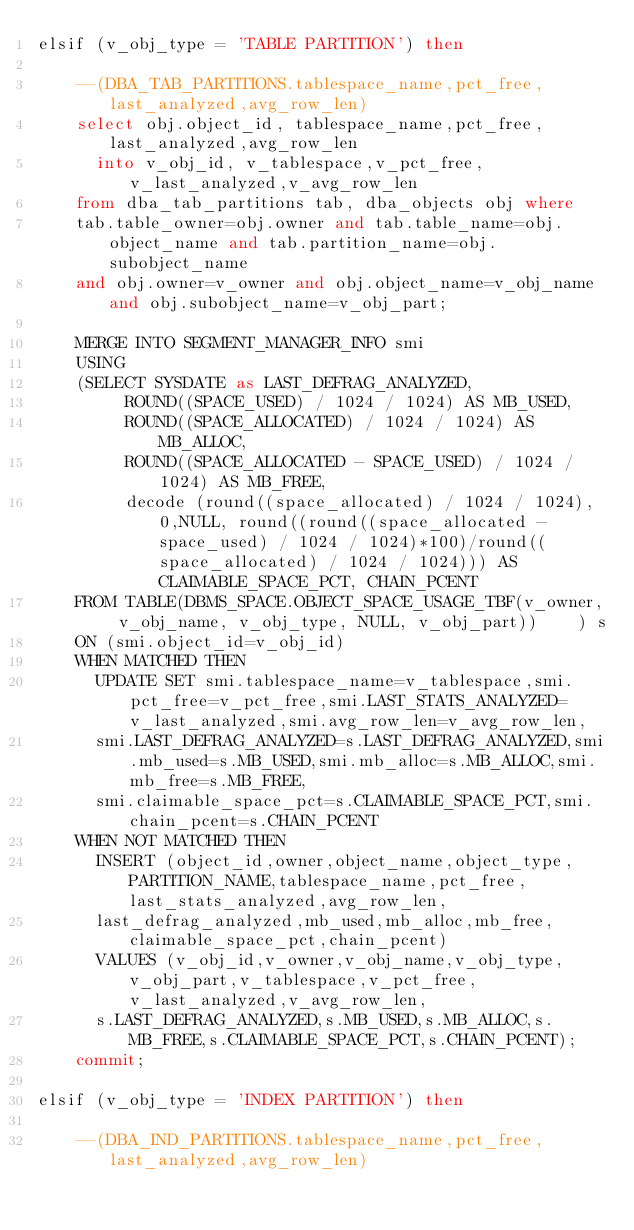Convert code to text. <code><loc_0><loc_0><loc_500><loc_500><_SQL_>elsif (v_obj_type = 'TABLE PARTITION') then

		--(DBA_TAB_PARTITIONS.tablespace_name,pct_free,last_analyzed,avg_row_len)
		select obj.object_id, tablespace_name,pct_free,last_analyzed,avg_row_len
		  into v_obj_id, v_tablespace,v_pct_free,v_last_analyzed,v_avg_row_len
		from dba_tab_partitions tab, dba_objects obj where
		tab.table_owner=obj.owner and tab.table_name=obj.object_name and tab.partition_name=obj.subobject_name
		and obj.owner=v_owner and obj.object_name=v_obj_name and obj.subobject_name=v_obj_part;
		
		MERGE INTO SEGMENT_MANAGER_INFO smi
		USING
		(SELECT SYSDATE as LAST_DEFRAG_ANALYZED,
			   ROUND((SPACE_USED) / 1024 / 1024) AS MB_USED,
			   ROUND((SPACE_ALLOCATED) / 1024 / 1024) AS MB_ALLOC,
			   ROUND((SPACE_ALLOCATED - SPACE_USED) / 1024 / 1024) AS MB_FREE,
			   decode (round((space_allocated) / 1024 / 1024), 0,NULL, round((round((space_allocated - space_used) / 1024 / 1024)*100)/round((space_allocated) / 1024 / 1024))) AS CLAIMABLE_SPACE_PCT, CHAIN_PCENT
		FROM TABLE(DBMS_SPACE.OBJECT_SPACE_USAGE_TBF(v_owner, v_obj_name, v_obj_type, NULL, v_obj_part))		) s
		ON (smi.object_id=v_obj_id)
		WHEN MATCHED THEN
			UPDATE SET smi.tablespace_name=v_tablespace,smi.pct_free=v_pct_free,smi.LAST_STATS_ANALYZED=v_last_analyzed,smi.avg_row_len=v_avg_row_len,
			smi.LAST_DEFRAG_ANALYZED=s.LAST_DEFRAG_ANALYZED,smi.mb_used=s.MB_USED,smi.mb_alloc=s.MB_ALLOC,smi.mb_free=s.MB_FREE,
			smi.claimable_space_pct=s.CLAIMABLE_SPACE_PCT,smi.chain_pcent=s.CHAIN_PCENT
		WHEN NOT MATCHED THEN
			INSERT (object_id,owner,object_name,object_type,PARTITION_NAME,tablespace_name,pct_free,last_stats_analyzed,avg_row_len,
			last_defrag_analyzed,mb_used,mb_alloc,mb_free,claimable_space_pct,chain_pcent)
			VALUES (v_obj_id,v_owner,v_obj_name,v_obj_type,v_obj_part,v_tablespace,v_pct_free,v_last_analyzed,v_avg_row_len,
			s.LAST_DEFRAG_ANALYZED,s.MB_USED,s.MB_ALLOC,s.MB_FREE,s.CLAIMABLE_SPACE_PCT,s.CHAIN_PCENT);
		commit;

elsif (v_obj_type = 'INDEX PARTITION') then

		--(DBA_IND_PARTITIONS.tablespace_name,pct_free,last_analyzed,avg_row_len)</code> 